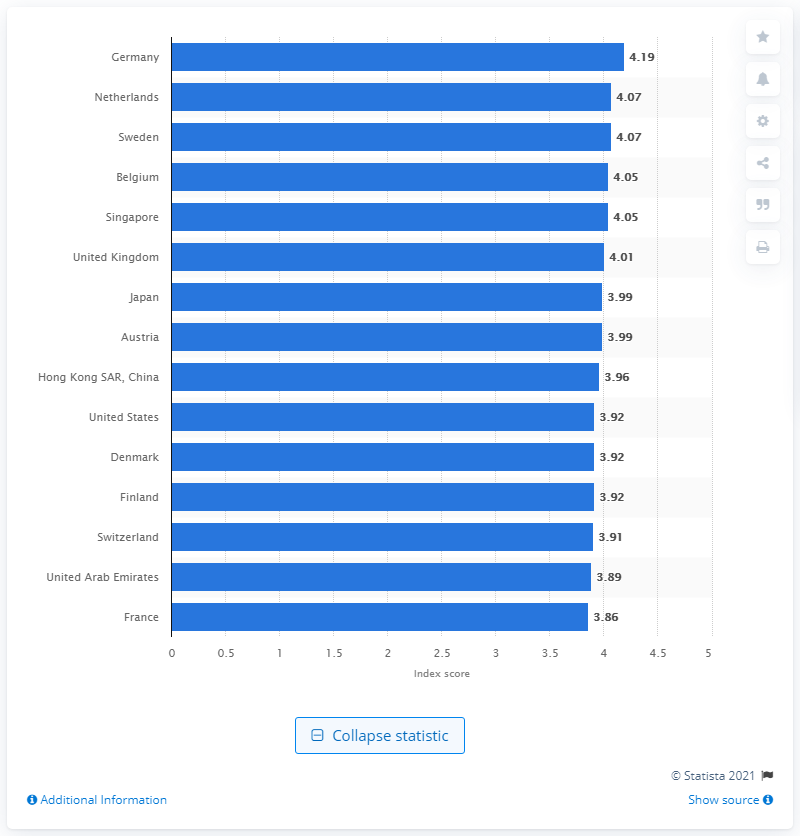Point out several critical features in this image. Germany was ranked as the leading logistics market in 2018, according to a recent assessment. According to the Logistics Performance Index score in 2018, Germany achieved a score of 4.19, which indicates a high level of logistics performance. 